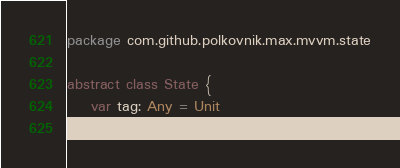Convert code to text. <code><loc_0><loc_0><loc_500><loc_500><_Kotlin_>package com.github.polkovnik.max.mvvm.state

abstract class State {
    var tag: Any = Unit
}</code> 